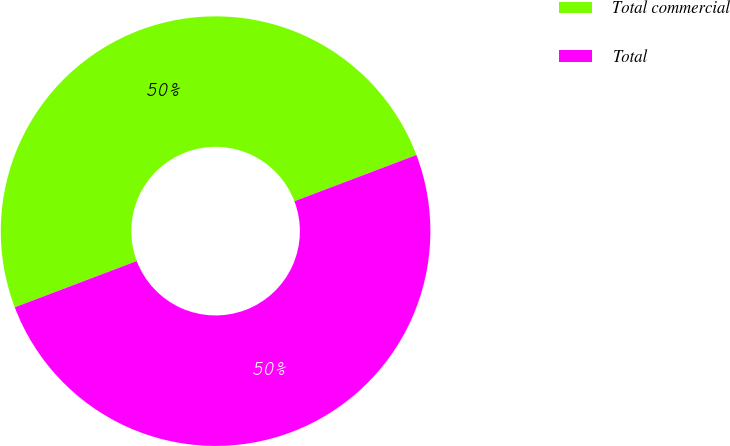<chart> <loc_0><loc_0><loc_500><loc_500><pie_chart><fcel>Total commercial<fcel>Total<nl><fcel>50.0%<fcel>50.0%<nl></chart> 